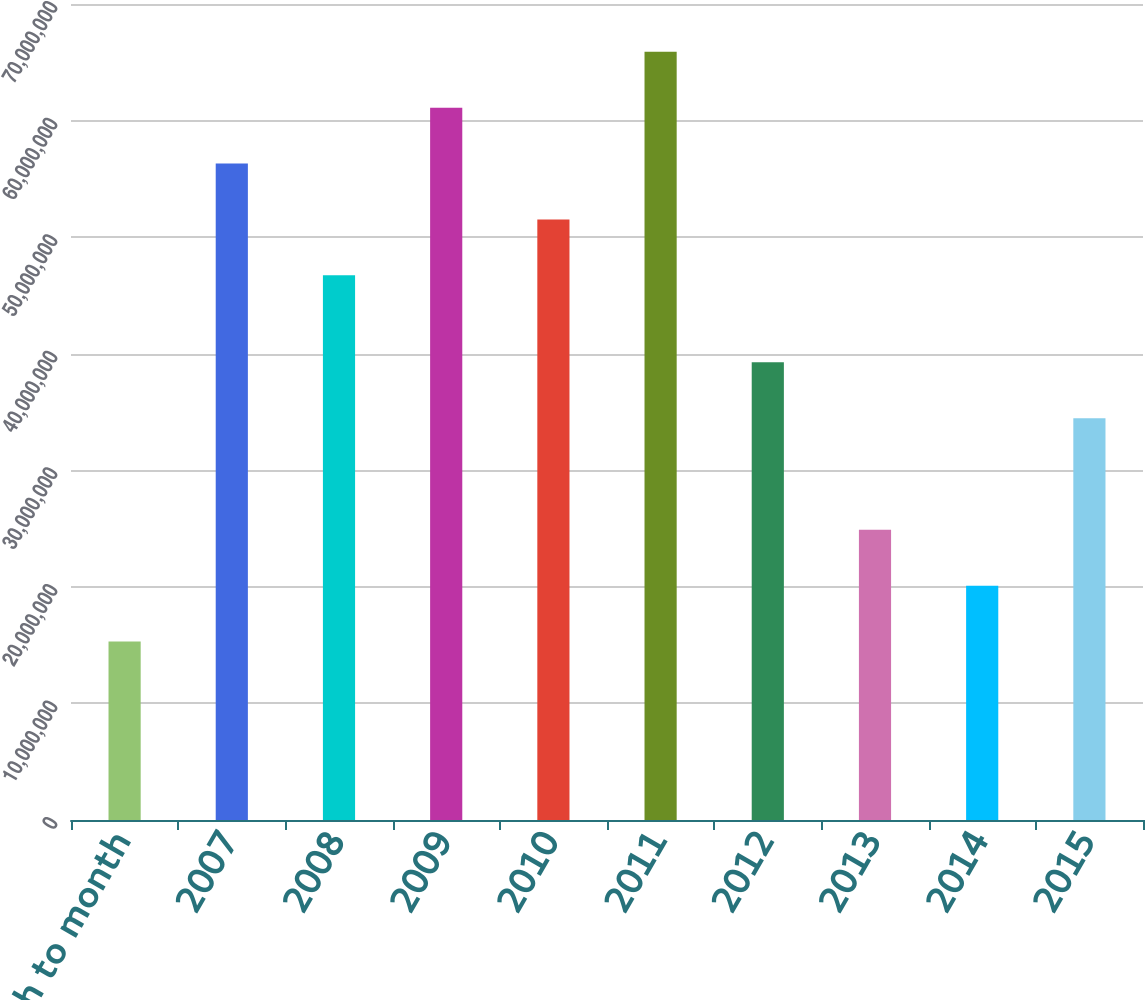<chart> <loc_0><loc_0><loc_500><loc_500><bar_chart><fcel>Month to month<fcel>2007<fcel>2008<fcel>2009<fcel>2010<fcel>2011<fcel>2012<fcel>2013<fcel>2014<fcel>2015<nl><fcel>1.5307e+07<fcel>5.63106e+07<fcel>4.6727e+07<fcel>6.11024e+07<fcel>5.15188e+07<fcel>6.58942e+07<fcel>3.9266e+07<fcel>2.48906e+07<fcel>2.00988e+07<fcel>3.44742e+07<nl></chart> 